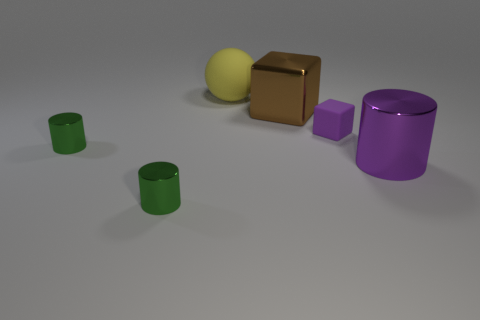Subtract all purple cubes. Subtract all brown cylinders. How many cubes are left? 1 Add 2 blocks. How many objects exist? 8 Subtract all balls. How many objects are left? 5 Add 1 tiny cyan things. How many tiny cyan things exist? 1 Subtract 1 purple cylinders. How many objects are left? 5 Subtract all large brown cylinders. Subtract all green things. How many objects are left? 4 Add 3 big brown things. How many big brown things are left? 4 